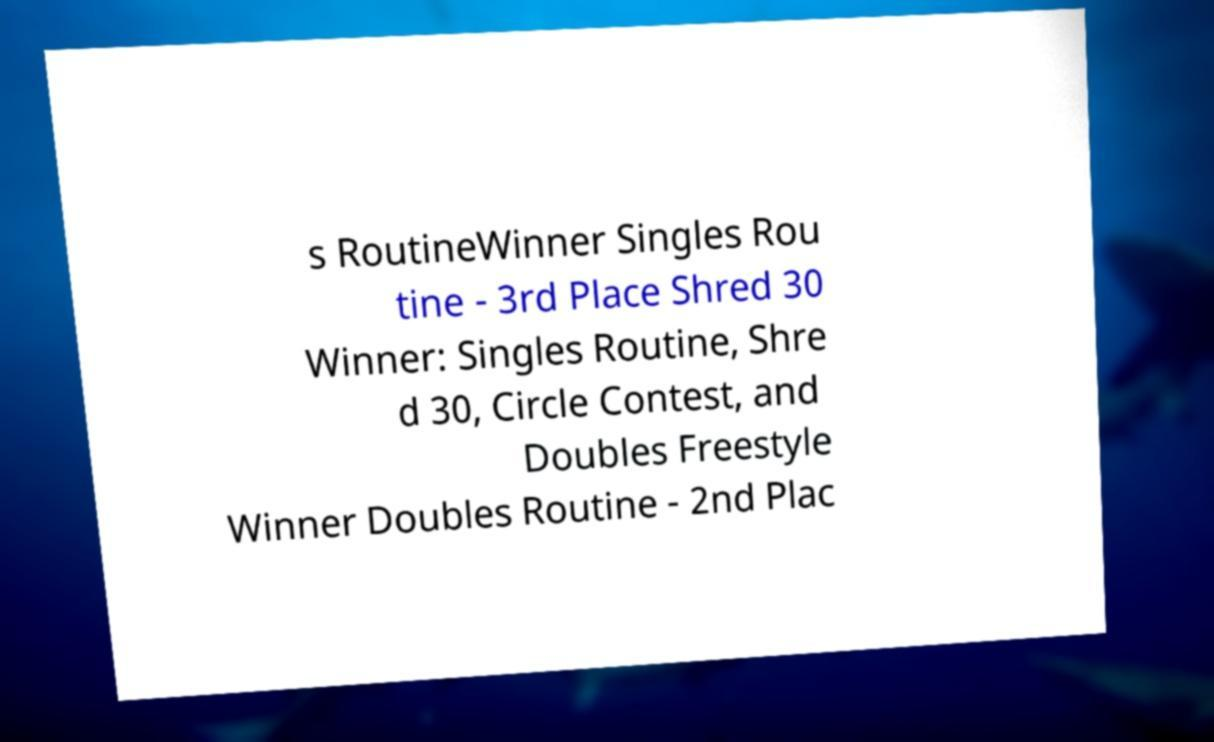I need the written content from this picture converted into text. Can you do that? s RoutineWinner Singles Rou tine - 3rd Place Shred 30 Winner: Singles Routine, Shre d 30, Circle Contest, and Doubles Freestyle Winner Doubles Routine - 2nd Plac 